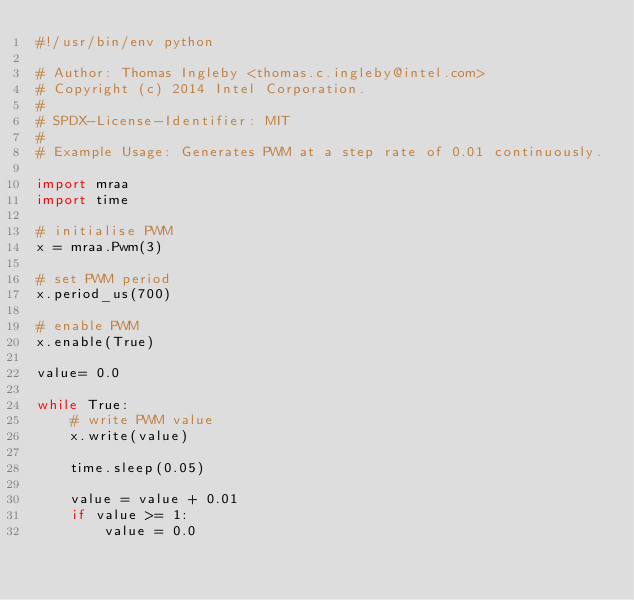<code> <loc_0><loc_0><loc_500><loc_500><_Python_>#!/usr/bin/env python

# Author: Thomas Ingleby <thomas.c.ingleby@intel.com>
# Copyright (c) 2014 Intel Corporation.
#
# SPDX-License-Identifier: MIT
#
# Example Usage: Generates PWM at a step rate of 0.01 continuously.

import mraa
import time

# initialise PWM
x = mraa.Pwm(3)

# set PWM period
x.period_us(700)

# enable PWM
x.enable(True)

value= 0.0

while True:
    # write PWM value
    x.write(value)

    time.sleep(0.05)

    value = value + 0.01
    if value >= 1:
        value = 0.0
</code> 